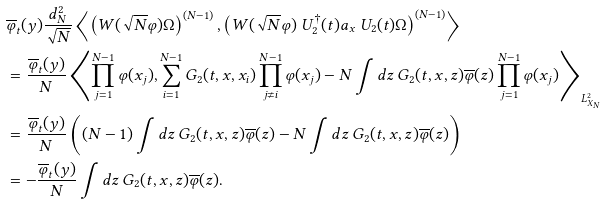Convert formula to latex. <formula><loc_0><loc_0><loc_500><loc_500>& \overline { \varphi } _ { t } ( y ) \frac { d _ { N } ^ { 2 } } { \sqrt { N } } \left \langle \left ( W ( \sqrt { N } \varphi ) \Omega \right ) ^ { ( N - 1 ) } , \left ( W ( \sqrt { N } \varphi ) \ U _ { 2 } ^ { \dag } ( t ) a _ { x } \ U _ { 2 } ( t ) \Omega \right ) ^ { ( N - 1 ) } \right \rangle \\ & = \frac { \overline { \varphi } _ { t } ( y ) } { N } \left \langle \prod _ { j = 1 } ^ { N - 1 } \varphi ( x _ { j } ) , \sum _ { i = 1 } ^ { N - 1 } G _ { 2 } ( t , x , x _ { i } ) \prod _ { j \neq i } ^ { N - 1 } \varphi ( x _ { j } ) - N \int d z \, G _ { 2 } ( t , x , z ) \overline { \varphi } ( z ) \prod _ { j = 1 } ^ { N - 1 } \varphi ( x _ { j } ) \right \rangle _ { L ^ { 2 } _ { X _ { N } } } \\ & = \frac { \overline { \varphi } _ { t } ( y ) } { N } \left ( ( N - 1 ) \int d z \, G _ { 2 } ( t , x , z ) \overline { \varphi } ( z ) - N \int d z \, G _ { 2 } ( t , x , z ) \overline { \varphi } ( z ) \right ) \\ & = - \frac { \overline { \varphi } _ { t } ( y ) } { N } \int d z \, G _ { 2 } ( t , x , z ) \overline { \varphi } ( z ) .</formula> 